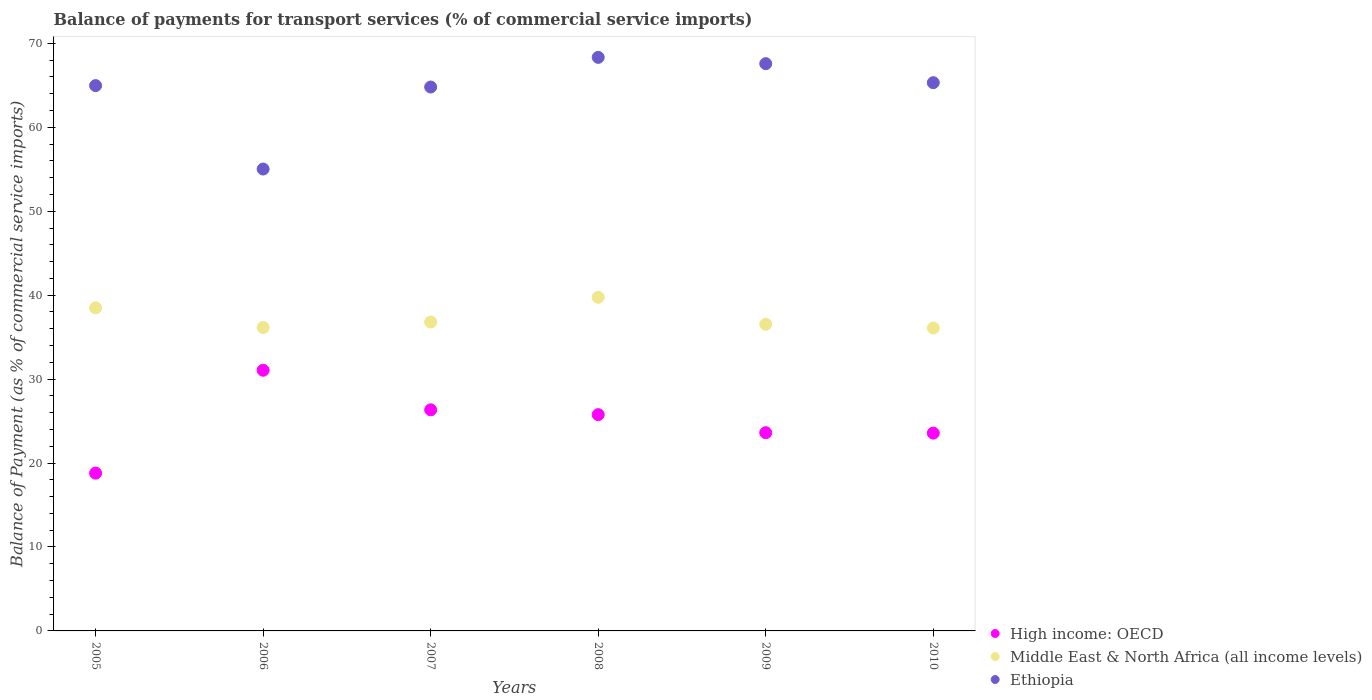How many different coloured dotlines are there?
Give a very brief answer. 3. What is the balance of payments for transport services in High income: OECD in 2007?
Offer a very short reply. 26.34. Across all years, what is the maximum balance of payments for transport services in Ethiopia?
Offer a very short reply. 68.33. Across all years, what is the minimum balance of payments for transport services in Ethiopia?
Your answer should be very brief. 55.03. In which year was the balance of payments for transport services in Middle East & North Africa (all income levels) maximum?
Keep it short and to the point. 2008. What is the total balance of payments for transport services in Ethiopia in the graph?
Offer a very short reply. 386.04. What is the difference between the balance of payments for transport services in Ethiopia in 2005 and that in 2010?
Ensure brevity in your answer.  -0.35. What is the difference between the balance of payments for transport services in Middle East & North Africa (all income levels) in 2008 and the balance of payments for transport services in Ethiopia in 2010?
Your answer should be compact. -25.58. What is the average balance of payments for transport services in Ethiopia per year?
Provide a succinct answer. 64.34. In the year 2005, what is the difference between the balance of payments for transport services in Middle East & North Africa (all income levels) and balance of payments for transport services in High income: OECD?
Provide a short and direct response. 19.69. What is the ratio of the balance of payments for transport services in High income: OECD in 2007 to that in 2010?
Your answer should be compact. 1.12. Is the balance of payments for transport services in High income: OECD in 2005 less than that in 2010?
Provide a short and direct response. Yes. Is the difference between the balance of payments for transport services in Middle East & North Africa (all income levels) in 2005 and 2008 greater than the difference between the balance of payments for transport services in High income: OECD in 2005 and 2008?
Provide a succinct answer. Yes. What is the difference between the highest and the second highest balance of payments for transport services in Ethiopia?
Ensure brevity in your answer.  0.75. What is the difference between the highest and the lowest balance of payments for transport services in High income: OECD?
Offer a terse response. 12.26. Is the sum of the balance of payments for transport services in Ethiopia in 2006 and 2009 greater than the maximum balance of payments for transport services in High income: OECD across all years?
Make the answer very short. Yes. Does the balance of payments for transport services in High income: OECD monotonically increase over the years?
Provide a succinct answer. No. Is the balance of payments for transport services in High income: OECD strictly greater than the balance of payments for transport services in Middle East & North Africa (all income levels) over the years?
Ensure brevity in your answer.  No. How many years are there in the graph?
Your answer should be compact. 6. What is the difference between two consecutive major ticks on the Y-axis?
Make the answer very short. 10. Are the values on the major ticks of Y-axis written in scientific E-notation?
Offer a very short reply. No. Does the graph contain any zero values?
Keep it short and to the point. No. How many legend labels are there?
Provide a succinct answer. 3. How are the legend labels stacked?
Offer a terse response. Vertical. What is the title of the graph?
Provide a succinct answer. Balance of payments for transport services (% of commercial service imports). What is the label or title of the X-axis?
Provide a succinct answer. Years. What is the label or title of the Y-axis?
Keep it short and to the point. Balance of Payment (as % of commercial service imports). What is the Balance of Payment (as % of commercial service imports) in High income: OECD in 2005?
Ensure brevity in your answer.  18.8. What is the Balance of Payment (as % of commercial service imports) in Middle East & North Africa (all income levels) in 2005?
Give a very brief answer. 38.49. What is the Balance of Payment (as % of commercial service imports) in Ethiopia in 2005?
Keep it short and to the point. 64.97. What is the Balance of Payment (as % of commercial service imports) in High income: OECD in 2006?
Give a very brief answer. 31.06. What is the Balance of Payment (as % of commercial service imports) in Middle East & North Africa (all income levels) in 2006?
Ensure brevity in your answer.  36.15. What is the Balance of Payment (as % of commercial service imports) in Ethiopia in 2006?
Your answer should be very brief. 55.03. What is the Balance of Payment (as % of commercial service imports) in High income: OECD in 2007?
Ensure brevity in your answer.  26.34. What is the Balance of Payment (as % of commercial service imports) of Middle East & North Africa (all income levels) in 2007?
Ensure brevity in your answer.  36.81. What is the Balance of Payment (as % of commercial service imports) in Ethiopia in 2007?
Give a very brief answer. 64.8. What is the Balance of Payment (as % of commercial service imports) of High income: OECD in 2008?
Your answer should be compact. 25.77. What is the Balance of Payment (as % of commercial service imports) in Middle East & North Africa (all income levels) in 2008?
Provide a succinct answer. 39.74. What is the Balance of Payment (as % of commercial service imports) in Ethiopia in 2008?
Give a very brief answer. 68.33. What is the Balance of Payment (as % of commercial service imports) in High income: OECD in 2009?
Give a very brief answer. 23.62. What is the Balance of Payment (as % of commercial service imports) of Middle East & North Africa (all income levels) in 2009?
Offer a terse response. 36.53. What is the Balance of Payment (as % of commercial service imports) of Ethiopia in 2009?
Offer a terse response. 67.58. What is the Balance of Payment (as % of commercial service imports) of High income: OECD in 2010?
Your response must be concise. 23.57. What is the Balance of Payment (as % of commercial service imports) of Middle East & North Africa (all income levels) in 2010?
Offer a terse response. 36.09. What is the Balance of Payment (as % of commercial service imports) of Ethiopia in 2010?
Your response must be concise. 65.32. Across all years, what is the maximum Balance of Payment (as % of commercial service imports) in High income: OECD?
Keep it short and to the point. 31.06. Across all years, what is the maximum Balance of Payment (as % of commercial service imports) in Middle East & North Africa (all income levels)?
Keep it short and to the point. 39.74. Across all years, what is the maximum Balance of Payment (as % of commercial service imports) in Ethiopia?
Provide a short and direct response. 68.33. Across all years, what is the minimum Balance of Payment (as % of commercial service imports) of High income: OECD?
Your answer should be compact. 18.8. Across all years, what is the minimum Balance of Payment (as % of commercial service imports) of Middle East & North Africa (all income levels)?
Offer a terse response. 36.09. Across all years, what is the minimum Balance of Payment (as % of commercial service imports) in Ethiopia?
Offer a terse response. 55.03. What is the total Balance of Payment (as % of commercial service imports) of High income: OECD in the graph?
Make the answer very short. 149.15. What is the total Balance of Payment (as % of commercial service imports) in Middle East & North Africa (all income levels) in the graph?
Provide a short and direct response. 223.81. What is the total Balance of Payment (as % of commercial service imports) of Ethiopia in the graph?
Provide a short and direct response. 386.04. What is the difference between the Balance of Payment (as % of commercial service imports) of High income: OECD in 2005 and that in 2006?
Give a very brief answer. -12.26. What is the difference between the Balance of Payment (as % of commercial service imports) of Middle East & North Africa (all income levels) in 2005 and that in 2006?
Give a very brief answer. 2.34. What is the difference between the Balance of Payment (as % of commercial service imports) in Ethiopia in 2005 and that in 2006?
Your answer should be very brief. 9.94. What is the difference between the Balance of Payment (as % of commercial service imports) in High income: OECD in 2005 and that in 2007?
Your answer should be compact. -7.54. What is the difference between the Balance of Payment (as % of commercial service imports) in Middle East & North Africa (all income levels) in 2005 and that in 2007?
Offer a very short reply. 1.68. What is the difference between the Balance of Payment (as % of commercial service imports) of Ethiopia in 2005 and that in 2007?
Your answer should be very brief. 0.17. What is the difference between the Balance of Payment (as % of commercial service imports) in High income: OECD in 2005 and that in 2008?
Keep it short and to the point. -6.97. What is the difference between the Balance of Payment (as % of commercial service imports) in Middle East & North Africa (all income levels) in 2005 and that in 2008?
Your answer should be compact. -1.25. What is the difference between the Balance of Payment (as % of commercial service imports) in Ethiopia in 2005 and that in 2008?
Provide a short and direct response. -3.37. What is the difference between the Balance of Payment (as % of commercial service imports) in High income: OECD in 2005 and that in 2009?
Provide a short and direct response. -4.82. What is the difference between the Balance of Payment (as % of commercial service imports) of Middle East & North Africa (all income levels) in 2005 and that in 2009?
Your answer should be compact. 1.96. What is the difference between the Balance of Payment (as % of commercial service imports) of Ethiopia in 2005 and that in 2009?
Make the answer very short. -2.61. What is the difference between the Balance of Payment (as % of commercial service imports) of High income: OECD in 2005 and that in 2010?
Provide a short and direct response. -4.77. What is the difference between the Balance of Payment (as % of commercial service imports) of Middle East & North Africa (all income levels) in 2005 and that in 2010?
Give a very brief answer. 2.4. What is the difference between the Balance of Payment (as % of commercial service imports) in Ethiopia in 2005 and that in 2010?
Give a very brief answer. -0.35. What is the difference between the Balance of Payment (as % of commercial service imports) of High income: OECD in 2006 and that in 2007?
Your answer should be compact. 4.72. What is the difference between the Balance of Payment (as % of commercial service imports) in Middle East & North Africa (all income levels) in 2006 and that in 2007?
Provide a succinct answer. -0.66. What is the difference between the Balance of Payment (as % of commercial service imports) in Ethiopia in 2006 and that in 2007?
Make the answer very short. -9.77. What is the difference between the Balance of Payment (as % of commercial service imports) of High income: OECD in 2006 and that in 2008?
Your answer should be very brief. 5.29. What is the difference between the Balance of Payment (as % of commercial service imports) in Middle East & North Africa (all income levels) in 2006 and that in 2008?
Offer a very short reply. -3.6. What is the difference between the Balance of Payment (as % of commercial service imports) of Ethiopia in 2006 and that in 2008?
Ensure brevity in your answer.  -13.31. What is the difference between the Balance of Payment (as % of commercial service imports) in High income: OECD in 2006 and that in 2009?
Your answer should be compact. 7.44. What is the difference between the Balance of Payment (as % of commercial service imports) of Middle East & North Africa (all income levels) in 2006 and that in 2009?
Provide a short and direct response. -0.38. What is the difference between the Balance of Payment (as % of commercial service imports) in Ethiopia in 2006 and that in 2009?
Keep it short and to the point. -12.56. What is the difference between the Balance of Payment (as % of commercial service imports) of High income: OECD in 2006 and that in 2010?
Your answer should be very brief. 7.49. What is the difference between the Balance of Payment (as % of commercial service imports) of Middle East & North Africa (all income levels) in 2006 and that in 2010?
Provide a succinct answer. 0.06. What is the difference between the Balance of Payment (as % of commercial service imports) of Ethiopia in 2006 and that in 2010?
Make the answer very short. -10.29. What is the difference between the Balance of Payment (as % of commercial service imports) in High income: OECD in 2007 and that in 2008?
Ensure brevity in your answer.  0.57. What is the difference between the Balance of Payment (as % of commercial service imports) of Middle East & North Africa (all income levels) in 2007 and that in 2008?
Offer a very short reply. -2.94. What is the difference between the Balance of Payment (as % of commercial service imports) of Ethiopia in 2007 and that in 2008?
Your answer should be compact. -3.53. What is the difference between the Balance of Payment (as % of commercial service imports) of High income: OECD in 2007 and that in 2009?
Your answer should be very brief. 2.73. What is the difference between the Balance of Payment (as % of commercial service imports) in Middle East & North Africa (all income levels) in 2007 and that in 2009?
Your answer should be compact. 0.27. What is the difference between the Balance of Payment (as % of commercial service imports) in Ethiopia in 2007 and that in 2009?
Ensure brevity in your answer.  -2.78. What is the difference between the Balance of Payment (as % of commercial service imports) in High income: OECD in 2007 and that in 2010?
Keep it short and to the point. 2.77. What is the difference between the Balance of Payment (as % of commercial service imports) in Middle East & North Africa (all income levels) in 2007 and that in 2010?
Give a very brief answer. 0.72. What is the difference between the Balance of Payment (as % of commercial service imports) of Ethiopia in 2007 and that in 2010?
Make the answer very short. -0.52. What is the difference between the Balance of Payment (as % of commercial service imports) in High income: OECD in 2008 and that in 2009?
Your answer should be very brief. 2.15. What is the difference between the Balance of Payment (as % of commercial service imports) in Middle East & North Africa (all income levels) in 2008 and that in 2009?
Make the answer very short. 3.21. What is the difference between the Balance of Payment (as % of commercial service imports) of Ethiopia in 2008 and that in 2009?
Make the answer very short. 0.75. What is the difference between the Balance of Payment (as % of commercial service imports) in High income: OECD in 2008 and that in 2010?
Your answer should be very brief. 2.2. What is the difference between the Balance of Payment (as % of commercial service imports) of Middle East & North Africa (all income levels) in 2008 and that in 2010?
Keep it short and to the point. 3.65. What is the difference between the Balance of Payment (as % of commercial service imports) of Ethiopia in 2008 and that in 2010?
Make the answer very short. 3.02. What is the difference between the Balance of Payment (as % of commercial service imports) of High income: OECD in 2009 and that in 2010?
Ensure brevity in your answer.  0.05. What is the difference between the Balance of Payment (as % of commercial service imports) of Middle East & North Africa (all income levels) in 2009 and that in 2010?
Your answer should be very brief. 0.44. What is the difference between the Balance of Payment (as % of commercial service imports) of Ethiopia in 2009 and that in 2010?
Your answer should be compact. 2.26. What is the difference between the Balance of Payment (as % of commercial service imports) of High income: OECD in 2005 and the Balance of Payment (as % of commercial service imports) of Middle East & North Africa (all income levels) in 2006?
Provide a short and direct response. -17.35. What is the difference between the Balance of Payment (as % of commercial service imports) of High income: OECD in 2005 and the Balance of Payment (as % of commercial service imports) of Ethiopia in 2006?
Ensure brevity in your answer.  -36.23. What is the difference between the Balance of Payment (as % of commercial service imports) in Middle East & North Africa (all income levels) in 2005 and the Balance of Payment (as % of commercial service imports) in Ethiopia in 2006?
Offer a very short reply. -16.54. What is the difference between the Balance of Payment (as % of commercial service imports) in High income: OECD in 2005 and the Balance of Payment (as % of commercial service imports) in Middle East & North Africa (all income levels) in 2007?
Make the answer very short. -18.01. What is the difference between the Balance of Payment (as % of commercial service imports) in High income: OECD in 2005 and the Balance of Payment (as % of commercial service imports) in Ethiopia in 2007?
Offer a very short reply. -46. What is the difference between the Balance of Payment (as % of commercial service imports) of Middle East & North Africa (all income levels) in 2005 and the Balance of Payment (as % of commercial service imports) of Ethiopia in 2007?
Keep it short and to the point. -26.31. What is the difference between the Balance of Payment (as % of commercial service imports) of High income: OECD in 2005 and the Balance of Payment (as % of commercial service imports) of Middle East & North Africa (all income levels) in 2008?
Your answer should be compact. -20.94. What is the difference between the Balance of Payment (as % of commercial service imports) in High income: OECD in 2005 and the Balance of Payment (as % of commercial service imports) in Ethiopia in 2008?
Offer a very short reply. -49.53. What is the difference between the Balance of Payment (as % of commercial service imports) in Middle East & North Africa (all income levels) in 2005 and the Balance of Payment (as % of commercial service imports) in Ethiopia in 2008?
Ensure brevity in your answer.  -29.84. What is the difference between the Balance of Payment (as % of commercial service imports) of High income: OECD in 2005 and the Balance of Payment (as % of commercial service imports) of Middle East & North Africa (all income levels) in 2009?
Provide a short and direct response. -17.73. What is the difference between the Balance of Payment (as % of commercial service imports) of High income: OECD in 2005 and the Balance of Payment (as % of commercial service imports) of Ethiopia in 2009?
Your answer should be very brief. -48.78. What is the difference between the Balance of Payment (as % of commercial service imports) of Middle East & North Africa (all income levels) in 2005 and the Balance of Payment (as % of commercial service imports) of Ethiopia in 2009?
Keep it short and to the point. -29.09. What is the difference between the Balance of Payment (as % of commercial service imports) in High income: OECD in 2005 and the Balance of Payment (as % of commercial service imports) in Middle East & North Africa (all income levels) in 2010?
Offer a very short reply. -17.29. What is the difference between the Balance of Payment (as % of commercial service imports) of High income: OECD in 2005 and the Balance of Payment (as % of commercial service imports) of Ethiopia in 2010?
Provide a succinct answer. -46.52. What is the difference between the Balance of Payment (as % of commercial service imports) of Middle East & North Africa (all income levels) in 2005 and the Balance of Payment (as % of commercial service imports) of Ethiopia in 2010?
Ensure brevity in your answer.  -26.83. What is the difference between the Balance of Payment (as % of commercial service imports) in High income: OECD in 2006 and the Balance of Payment (as % of commercial service imports) in Middle East & North Africa (all income levels) in 2007?
Give a very brief answer. -5.75. What is the difference between the Balance of Payment (as % of commercial service imports) of High income: OECD in 2006 and the Balance of Payment (as % of commercial service imports) of Ethiopia in 2007?
Make the answer very short. -33.74. What is the difference between the Balance of Payment (as % of commercial service imports) of Middle East & North Africa (all income levels) in 2006 and the Balance of Payment (as % of commercial service imports) of Ethiopia in 2007?
Keep it short and to the point. -28.65. What is the difference between the Balance of Payment (as % of commercial service imports) of High income: OECD in 2006 and the Balance of Payment (as % of commercial service imports) of Middle East & North Africa (all income levels) in 2008?
Your answer should be very brief. -8.69. What is the difference between the Balance of Payment (as % of commercial service imports) of High income: OECD in 2006 and the Balance of Payment (as % of commercial service imports) of Ethiopia in 2008?
Offer a very short reply. -37.28. What is the difference between the Balance of Payment (as % of commercial service imports) in Middle East & North Africa (all income levels) in 2006 and the Balance of Payment (as % of commercial service imports) in Ethiopia in 2008?
Offer a very short reply. -32.19. What is the difference between the Balance of Payment (as % of commercial service imports) in High income: OECD in 2006 and the Balance of Payment (as % of commercial service imports) in Middle East & North Africa (all income levels) in 2009?
Give a very brief answer. -5.47. What is the difference between the Balance of Payment (as % of commercial service imports) in High income: OECD in 2006 and the Balance of Payment (as % of commercial service imports) in Ethiopia in 2009?
Offer a terse response. -36.53. What is the difference between the Balance of Payment (as % of commercial service imports) in Middle East & North Africa (all income levels) in 2006 and the Balance of Payment (as % of commercial service imports) in Ethiopia in 2009?
Offer a very short reply. -31.44. What is the difference between the Balance of Payment (as % of commercial service imports) of High income: OECD in 2006 and the Balance of Payment (as % of commercial service imports) of Middle East & North Africa (all income levels) in 2010?
Provide a short and direct response. -5.03. What is the difference between the Balance of Payment (as % of commercial service imports) of High income: OECD in 2006 and the Balance of Payment (as % of commercial service imports) of Ethiopia in 2010?
Your response must be concise. -34.26. What is the difference between the Balance of Payment (as % of commercial service imports) of Middle East & North Africa (all income levels) in 2006 and the Balance of Payment (as % of commercial service imports) of Ethiopia in 2010?
Keep it short and to the point. -29.17. What is the difference between the Balance of Payment (as % of commercial service imports) in High income: OECD in 2007 and the Balance of Payment (as % of commercial service imports) in Middle East & North Africa (all income levels) in 2008?
Give a very brief answer. -13.4. What is the difference between the Balance of Payment (as % of commercial service imports) of High income: OECD in 2007 and the Balance of Payment (as % of commercial service imports) of Ethiopia in 2008?
Your answer should be compact. -41.99. What is the difference between the Balance of Payment (as % of commercial service imports) in Middle East & North Africa (all income levels) in 2007 and the Balance of Payment (as % of commercial service imports) in Ethiopia in 2008?
Provide a succinct answer. -31.53. What is the difference between the Balance of Payment (as % of commercial service imports) in High income: OECD in 2007 and the Balance of Payment (as % of commercial service imports) in Middle East & North Africa (all income levels) in 2009?
Ensure brevity in your answer.  -10.19. What is the difference between the Balance of Payment (as % of commercial service imports) of High income: OECD in 2007 and the Balance of Payment (as % of commercial service imports) of Ethiopia in 2009?
Your answer should be compact. -41.24. What is the difference between the Balance of Payment (as % of commercial service imports) of Middle East & North Africa (all income levels) in 2007 and the Balance of Payment (as % of commercial service imports) of Ethiopia in 2009?
Ensure brevity in your answer.  -30.78. What is the difference between the Balance of Payment (as % of commercial service imports) in High income: OECD in 2007 and the Balance of Payment (as % of commercial service imports) in Middle East & North Africa (all income levels) in 2010?
Keep it short and to the point. -9.75. What is the difference between the Balance of Payment (as % of commercial service imports) in High income: OECD in 2007 and the Balance of Payment (as % of commercial service imports) in Ethiopia in 2010?
Ensure brevity in your answer.  -38.98. What is the difference between the Balance of Payment (as % of commercial service imports) in Middle East & North Africa (all income levels) in 2007 and the Balance of Payment (as % of commercial service imports) in Ethiopia in 2010?
Your answer should be compact. -28.51. What is the difference between the Balance of Payment (as % of commercial service imports) in High income: OECD in 2008 and the Balance of Payment (as % of commercial service imports) in Middle East & North Africa (all income levels) in 2009?
Keep it short and to the point. -10.76. What is the difference between the Balance of Payment (as % of commercial service imports) of High income: OECD in 2008 and the Balance of Payment (as % of commercial service imports) of Ethiopia in 2009?
Your answer should be compact. -41.82. What is the difference between the Balance of Payment (as % of commercial service imports) of Middle East & North Africa (all income levels) in 2008 and the Balance of Payment (as % of commercial service imports) of Ethiopia in 2009?
Offer a terse response. -27.84. What is the difference between the Balance of Payment (as % of commercial service imports) in High income: OECD in 2008 and the Balance of Payment (as % of commercial service imports) in Middle East & North Africa (all income levels) in 2010?
Give a very brief answer. -10.32. What is the difference between the Balance of Payment (as % of commercial service imports) of High income: OECD in 2008 and the Balance of Payment (as % of commercial service imports) of Ethiopia in 2010?
Your answer should be very brief. -39.55. What is the difference between the Balance of Payment (as % of commercial service imports) in Middle East & North Africa (all income levels) in 2008 and the Balance of Payment (as % of commercial service imports) in Ethiopia in 2010?
Give a very brief answer. -25.58. What is the difference between the Balance of Payment (as % of commercial service imports) of High income: OECD in 2009 and the Balance of Payment (as % of commercial service imports) of Middle East & North Africa (all income levels) in 2010?
Offer a terse response. -12.47. What is the difference between the Balance of Payment (as % of commercial service imports) in High income: OECD in 2009 and the Balance of Payment (as % of commercial service imports) in Ethiopia in 2010?
Offer a terse response. -41.7. What is the difference between the Balance of Payment (as % of commercial service imports) of Middle East & North Africa (all income levels) in 2009 and the Balance of Payment (as % of commercial service imports) of Ethiopia in 2010?
Offer a terse response. -28.79. What is the average Balance of Payment (as % of commercial service imports) of High income: OECD per year?
Your answer should be very brief. 24.86. What is the average Balance of Payment (as % of commercial service imports) in Middle East & North Africa (all income levels) per year?
Your answer should be compact. 37.3. What is the average Balance of Payment (as % of commercial service imports) of Ethiopia per year?
Provide a succinct answer. 64.34. In the year 2005, what is the difference between the Balance of Payment (as % of commercial service imports) of High income: OECD and Balance of Payment (as % of commercial service imports) of Middle East & North Africa (all income levels)?
Your response must be concise. -19.69. In the year 2005, what is the difference between the Balance of Payment (as % of commercial service imports) in High income: OECD and Balance of Payment (as % of commercial service imports) in Ethiopia?
Make the answer very short. -46.17. In the year 2005, what is the difference between the Balance of Payment (as % of commercial service imports) in Middle East & North Africa (all income levels) and Balance of Payment (as % of commercial service imports) in Ethiopia?
Keep it short and to the point. -26.48. In the year 2006, what is the difference between the Balance of Payment (as % of commercial service imports) in High income: OECD and Balance of Payment (as % of commercial service imports) in Middle East & North Africa (all income levels)?
Provide a succinct answer. -5.09. In the year 2006, what is the difference between the Balance of Payment (as % of commercial service imports) in High income: OECD and Balance of Payment (as % of commercial service imports) in Ethiopia?
Ensure brevity in your answer.  -23.97. In the year 2006, what is the difference between the Balance of Payment (as % of commercial service imports) in Middle East & North Africa (all income levels) and Balance of Payment (as % of commercial service imports) in Ethiopia?
Your answer should be compact. -18.88. In the year 2007, what is the difference between the Balance of Payment (as % of commercial service imports) of High income: OECD and Balance of Payment (as % of commercial service imports) of Middle East & North Africa (all income levels)?
Keep it short and to the point. -10.47. In the year 2007, what is the difference between the Balance of Payment (as % of commercial service imports) of High income: OECD and Balance of Payment (as % of commercial service imports) of Ethiopia?
Keep it short and to the point. -38.46. In the year 2007, what is the difference between the Balance of Payment (as % of commercial service imports) of Middle East & North Africa (all income levels) and Balance of Payment (as % of commercial service imports) of Ethiopia?
Provide a succinct answer. -27.99. In the year 2008, what is the difference between the Balance of Payment (as % of commercial service imports) in High income: OECD and Balance of Payment (as % of commercial service imports) in Middle East & North Africa (all income levels)?
Keep it short and to the point. -13.98. In the year 2008, what is the difference between the Balance of Payment (as % of commercial service imports) in High income: OECD and Balance of Payment (as % of commercial service imports) in Ethiopia?
Offer a very short reply. -42.57. In the year 2008, what is the difference between the Balance of Payment (as % of commercial service imports) in Middle East & North Africa (all income levels) and Balance of Payment (as % of commercial service imports) in Ethiopia?
Your answer should be very brief. -28.59. In the year 2009, what is the difference between the Balance of Payment (as % of commercial service imports) of High income: OECD and Balance of Payment (as % of commercial service imports) of Middle East & North Africa (all income levels)?
Give a very brief answer. -12.92. In the year 2009, what is the difference between the Balance of Payment (as % of commercial service imports) of High income: OECD and Balance of Payment (as % of commercial service imports) of Ethiopia?
Provide a short and direct response. -43.97. In the year 2009, what is the difference between the Balance of Payment (as % of commercial service imports) in Middle East & North Africa (all income levels) and Balance of Payment (as % of commercial service imports) in Ethiopia?
Provide a short and direct response. -31.05. In the year 2010, what is the difference between the Balance of Payment (as % of commercial service imports) of High income: OECD and Balance of Payment (as % of commercial service imports) of Middle East & North Africa (all income levels)?
Ensure brevity in your answer.  -12.52. In the year 2010, what is the difference between the Balance of Payment (as % of commercial service imports) of High income: OECD and Balance of Payment (as % of commercial service imports) of Ethiopia?
Give a very brief answer. -41.75. In the year 2010, what is the difference between the Balance of Payment (as % of commercial service imports) of Middle East & North Africa (all income levels) and Balance of Payment (as % of commercial service imports) of Ethiopia?
Keep it short and to the point. -29.23. What is the ratio of the Balance of Payment (as % of commercial service imports) of High income: OECD in 2005 to that in 2006?
Keep it short and to the point. 0.61. What is the ratio of the Balance of Payment (as % of commercial service imports) in Middle East & North Africa (all income levels) in 2005 to that in 2006?
Ensure brevity in your answer.  1.06. What is the ratio of the Balance of Payment (as % of commercial service imports) in Ethiopia in 2005 to that in 2006?
Give a very brief answer. 1.18. What is the ratio of the Balance of Payment (as % of commercial service imports) of High income: OECD in 2005 to that in 2007?
Your response must be concise. 0.71. What is the ratio of the Balance of Payment (as % of commercial service imports) of Middle East & North Africa (all income levels) in 2005 to that in 2007?
Offer a terse response. 1.05. What is the ratio of the Balance of Payment (as % of commercial service imports) of Ethiopia in 2005 to that in 2007?
Your answer should be very brief. 1. What is the ratio of the Balance of Payment (as % of commercial service imports) in High income: OECD in 2005 to that in 2008?
Offer a terse response. 0.73. What is the ratio of the Balance of Payment (as % of commercial service imports) in Middle East & North Africa (all income levels) in 2005 to that in 2008?
Provide a short and direct response. 0.97. What is the ratio of the Balance of Payment (as % of commercial service imports) in Ethiopia in 2005 to that in 2008?
Offer a very short reply. 0.95. What is the ratio of the Balance of Payment (as % of commercial service imports) of High income: OECD in 2005 to that in 2009?
Offer a terse response. 0.8. What is the ratio of the Balance of Payment (as % of commercial service imports) of Middle East & North Africa (all income levels) in 2005 to that in 2009?
Keep it short and to the point. 1.05. What is the ratio of the Balance of Payment (as % of commercial service imports) in Ethiopia in 2005 to that in 2009?
Make the answer very short. 0.96. What is the ratio of the Balance of Payment (as % of commercial service imports) in High income: OECD in 2005 to that in 2010?
Your answer should be very brief. 0.8. What is the ratio of the Balance of Payment (as % of commercial service imports) of Middle East & North Africa (all income levels) in 2005 to that in 2010?
Provide a short and direct response. 1.07. What is the ratio of the Balance of Payment (as % of commercial service imports) in Ethiopia in 2005 to that in 2010?
Make the answer very short. 0.99. What is the ratio of the Balance of Payment (as % of commercial service imports) of High income: OECD in 2006 to that in 2007?
Provide a short and direct response. 1.18. What is the ratio of the Balance of Payment (as % of commercial service imports) in Middle East & North Africa (all income levels) in 2006 to that in 2007?
Provide a succinct answer. 0.98. What is the ratio of the Balance of Payment (as % of commercial service imports) in Ethiopia in 2006 to that in 2007?
Your response must be concise. 0.85. What is the ratio of the Balance of Payment (as % of commercial service imports) of High income: OECD in 2006 to that in 2008?
Provide a succinct answer. 1.21. What is the ratio of the Balance of Payment (as % of commercial service imports) in Middle East & North Africa (all income levels) in 2006 to that in 2008?
Keep it short and to the point. 0.91. What is the ratio of the Balance of Payment (as % of commercial service imports) of Ethiopia in 2006 to that in 2008?
Make the answer very short. 0.81. What is the ratio of the Balance of Payment (as % of commercial service imports) in High income: OECD in 2006 to that in 2009?
Offer a terse response. 1.32. What is the ratio of the Balance of Payment (as % of commercial service imports) of Middle East & North Africa (all income levels) in 2006 to that in 2009?
Your answer should be very brief. 0.99. What is the ratio of the Balance of Payment (as % of commercial service imports) of Ethiopia in 2006 to that in 2009?
Keep it short and to the point. 0.81. What is the ratio of the Balance of Payment (as % of commercial service imports) of High income: OECD in 2006 to that in 2010?
Your response must be concise. 1.32. What is the ratio of the Balance of Payment (as % of commercial service imports) of Ethiopia in 2006 to that in 2010?
Give a very brief answer. 0.84. What is the ratio of the Balance of Payment (as % of commercial service imports) in High income: OECD in 2007 to that in 2008?
Make the answer very short. 1.02. What is the ratio of the Balance of Payment (as % of commercial service imports) in Middle East & North Africa (all income levels) in 2007 to that in 2008?
Provide a succinct answer. 0.93. What is the ratio of the Balance of Payment (as % of commercial service imports) in Ethiopia in 2007 to that in 2008?
Ensure brevity in your answer.  0.95. What is the ratio of the Balance of Payment (as % of commercial service imports) of High income: OECD in 2007 to that in 2009?
Offer a terse response. 1.12. What is the ratio of the Balance of Payment (as % of commercial service imports) of Middle East & North Africa (all income levels) in 2007 to that in 2009?
Offer a very short reply. 1.01. What is the ratio of the Balance of Payment (as % of commercial service imports) of Ethiopia in 2007 to that in 2009?
Ensure brevity in your answer.  0.96. What is the ratio of the Balance of Payment (as % of commercial service imports) in High income: OECD in 2007 to that in 2010?
Your answer should be compact. 1.12. What is the ratio of the Balance of Payment (as % of commercial service imports) in Middle East & North Africa (all income levels) in 2007 to that in 2010?
Make the answer very short. 1.02. What is the ratio of the Balance of Payment (as % of commercial service imports) of High income: OECD in 2008 to that in 2009?
Your answer should be compact. 1.09. What is the ratio of the Balance of Payment (as % of commercial service imports) of Middle East & North Africa (all income levels) in 2008 to that in 2009?
Your answer should be compact. 1.09. What is the ratio of the Balance of Payment (as % of commercial service imports) in Ethiopia in 2008 to that in 2009?
Offer a terse response. 1.01. What is the ratio of the Balance of Payment (as % of commercial service imports) of High income: OECD in 2008 to that in 2010?
Make the answer very short. 1.09. What is the ratio of the Balance of Payment (as % of commercial service imports) of Middle East & North Africa (all income levels) in 2008 to that in 2010?
Give a very brief answer. 1.1. What is the ratio of the Balance of Payment (as % of commercial service imports) in Ethiopia in 2008 to that in 2010?
Provide a short and direct response. 1.05. What is the ratio of the Balance of Payment (as % of commercial service imports) in Middle East & North Africa (all income levels) in 2009 to that in 2010?
Give a very brief answer. 1.01. What is the ratio of the Balance of Payment (as % of commercial service imports) in Ethiopia in 2009 to that in 2010?
Keep it short and to the point. 1.03. What is the difference between the highest and the second highest Balance of Payment (as % of commercial service imports) of High income: OECD?
Your answer should be very brief. 4.72. What is the difference between the highest and the second highest Balance of Payment (as % of commercial service imports) in Middle East & North Africa (all income levels)?
Your answer should be very brief. 1.25. What is the difference between the highest and the second highest Balance of Payment (as % of commercial service imports) of Ethiopia?
Offer a very short reply. 0.75. What is the difference between the highest and the lowest Balance of Payment (as % of commercial service imports) of High income: OECD?
Provide a succinct answer. 12.26. What is the difference between the highest and the lowest Balance of Payment (as % of commercial service imports) in Middle East & North Africa (all income levels)?
Ensure brevity in your answer.  3.65. What is the difference between the highest and the lowest Balance of Payment (as % of commercial service imports) in Ethiopia?
Provide a succinct answer. 13.31. 